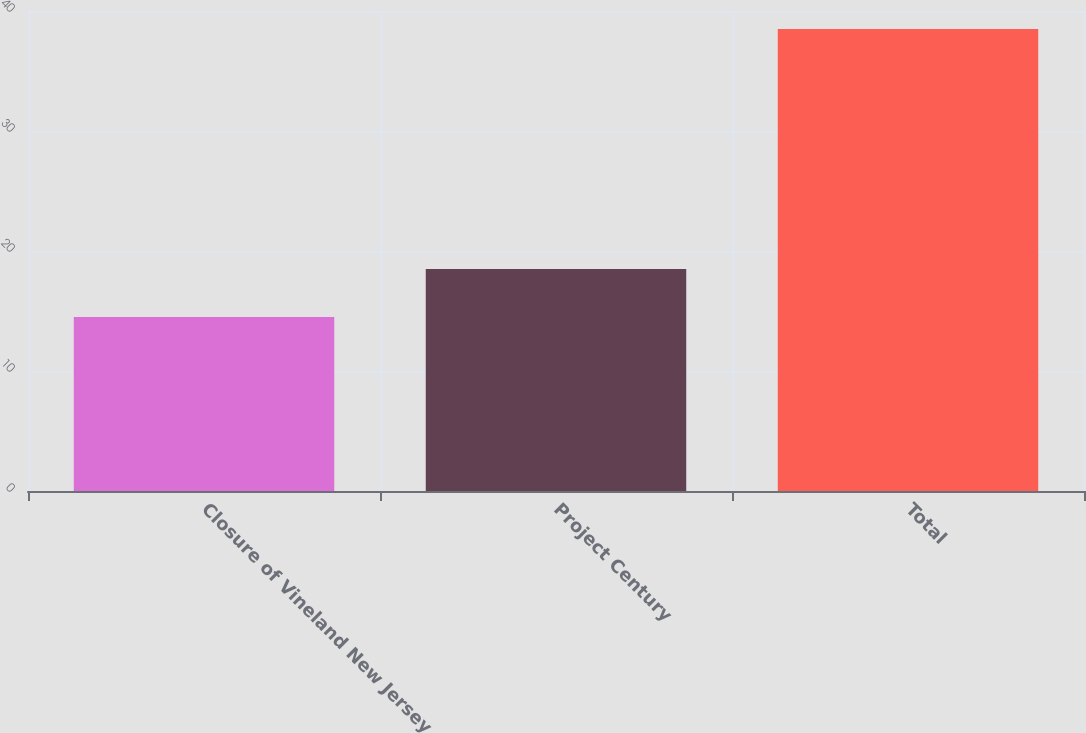Convert chart to OTSL. <chart><loc_0><loc_0><loc_500><loc_500><bar_chart><fcel>Closure of Vineland New Jersey<fcel>Project Century<fcel>Total<nl><fcel>14.5<fcel>18.5<fcel>38.5<nl></chart> 